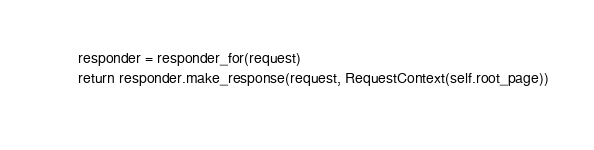<code> <loc_0><loc_0><loc_500><loc_500><_Python_>        responder = responder_for(request)
        return responder.make_response(request, RequestContext(self.root_page))
        
</code> 